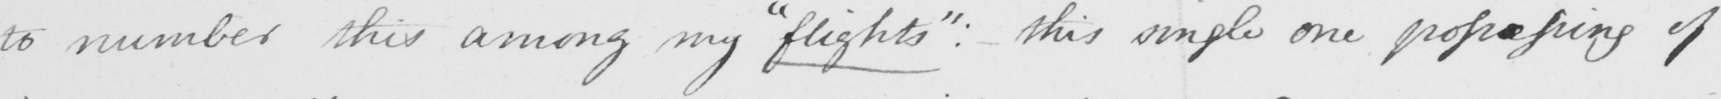Transcribe the text shown in this historical manuscript line. to number this among my  " flights "  :  this simple one possessing of 